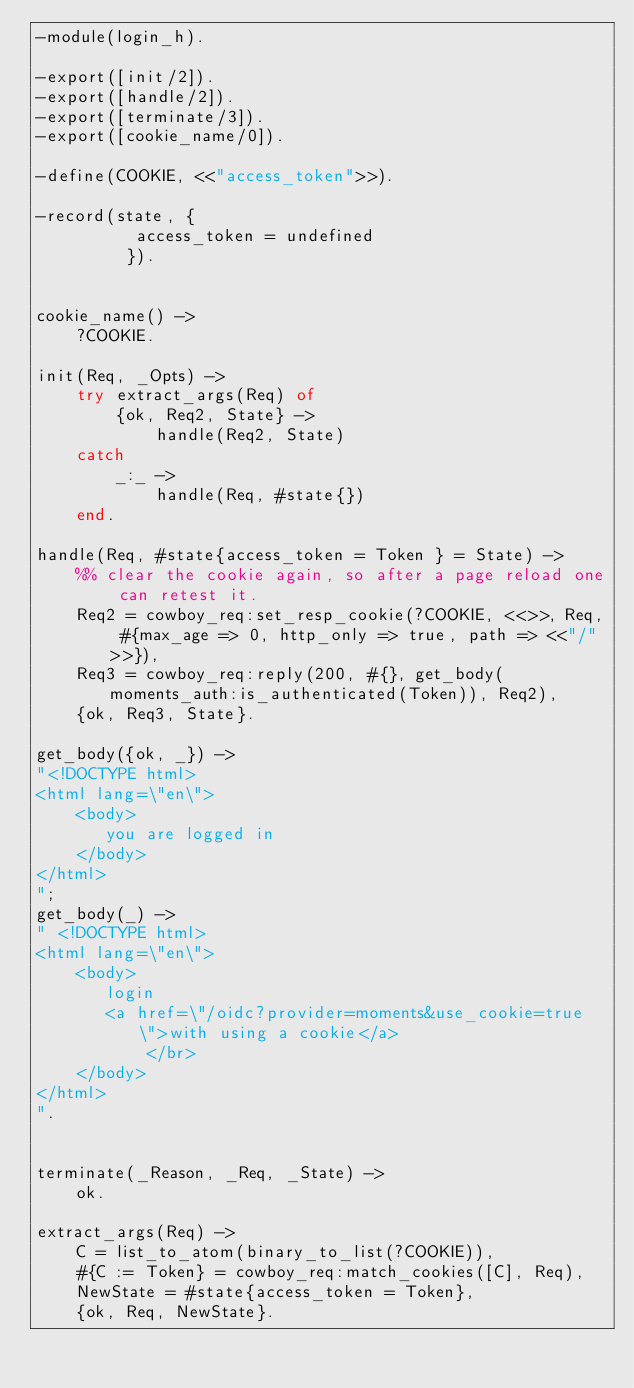Convert code to text. <code><loc_0><loc_0><loc_500><loc_500><_Erlang_>-module(login_h).

-export([init/2]).
-export([handle/2]).
-export([terminate/3]).
-export([cookie_name/0]).

-define(COOKIE, <<"access_token">>).

-record(state, {
          access_token = undefined
         }).


cookie_name() ->
    ?COOKIE.

init(Req, _Opts) ->
    try extract_args(Req) of
        {ok, Req2, State} ->
            handle(Req2, State)
    catch
        _:_ ->
            handle(Req, #state{})
    end.

handle(Req, #state{access_token = Token } = State) ->
    %% clear the cookie again, so after a page reload one can retest it.
    Req2 = cowboy_req:set_resp_cookie(?COOKIE, <<>>, Req, #{max_age => 0, http_only => true, path => <<"/">>}),
    Req3 = cowboy_req:reply(200, #{}, get_body(moments_auth:is_authenticated(Token)), Req2),
    {ok, Req3, State}.

get_body({ok, _}) ->
"<!DOCTYPE html>
<html lang=\"en\">
    <body>
	   you are logged in
    </body>
</html>
";
get_body(_) ->
" <!DOCTYPE html>
<html lang=\"en\">
    <body>
	   login
	   <a href=\"/oidc?provider=moments&use_cookie=true\">with using a cookie</a>
           </br>
    </body>
</html>
".


terminate(_Reason, _Req, _State) ->
    ok.

extract_args(Req) ->
    C = list_to_atom(binary_to_list(?COOKIE)),
    #{C := Token} = cowboy_req:match_cookies([C], Req),
    NewState = #state{access_token = Token},
    {ok, Req, NewState}.
</code> 